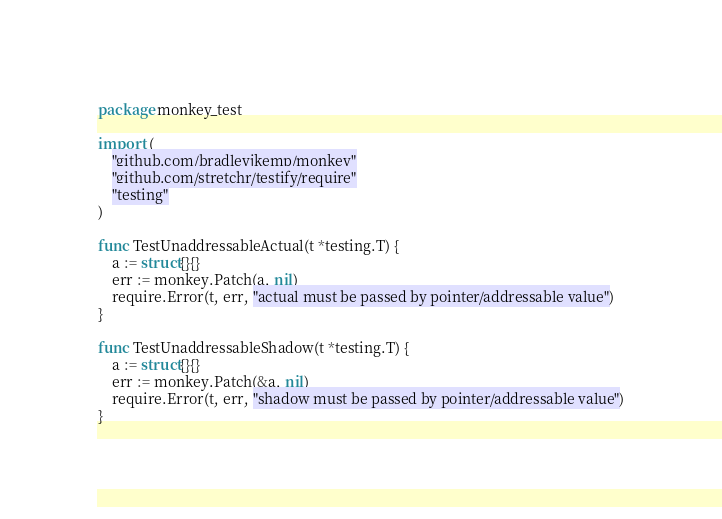<code> <loc_0><loc_0><loc_500><loc_500><_Go_>package monkey_test

import (
	"github.com/bradleyjkemp/monkey"
	"github.com/stretchr/testify/require"
	"testing"
)

func TestUnaddressableActual(t *testing.T) {
	a := struct{}{}
	err := monkey.Patch(a, nil)
	require.Error(t, err, "actual must be passed by pointer/addressable value")
}

func TestUnaddressableShadow(t *testing.T) {
	a := struct{}{}
	err := monkey.Patch(&a, nil)
	require.Error(t, err, "shadow must be passed by pointer/addressable value")
}
</code> 